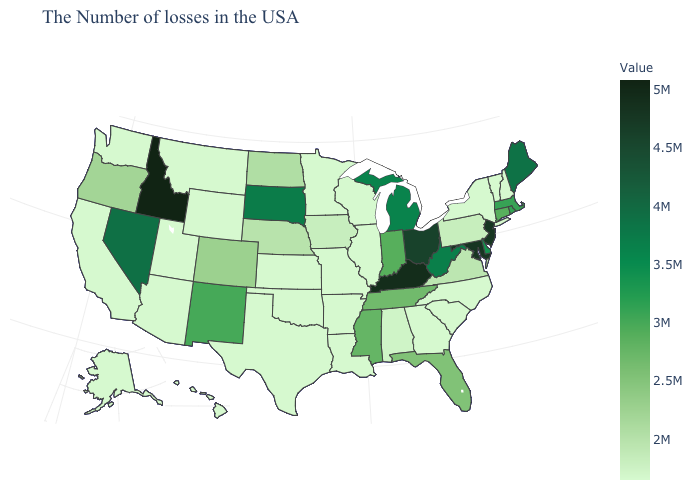Among the states that border Illinois , which have the lowest value?
Keep it brief. Wisconsin, Missouri. Among the states that border Florida , does Alabama have the lowest value?
Be succinct. No. Does Arizona have the lowest value in the West?
Write a very short answer. Yes. Does New Jersey have the highest value in the USA?
Quick response, please. No. Does the map have missing data?
Write a very short answer. No. Among the states that border Rhode Island , which have the lowest value?
Short answer required. Connecticut. 